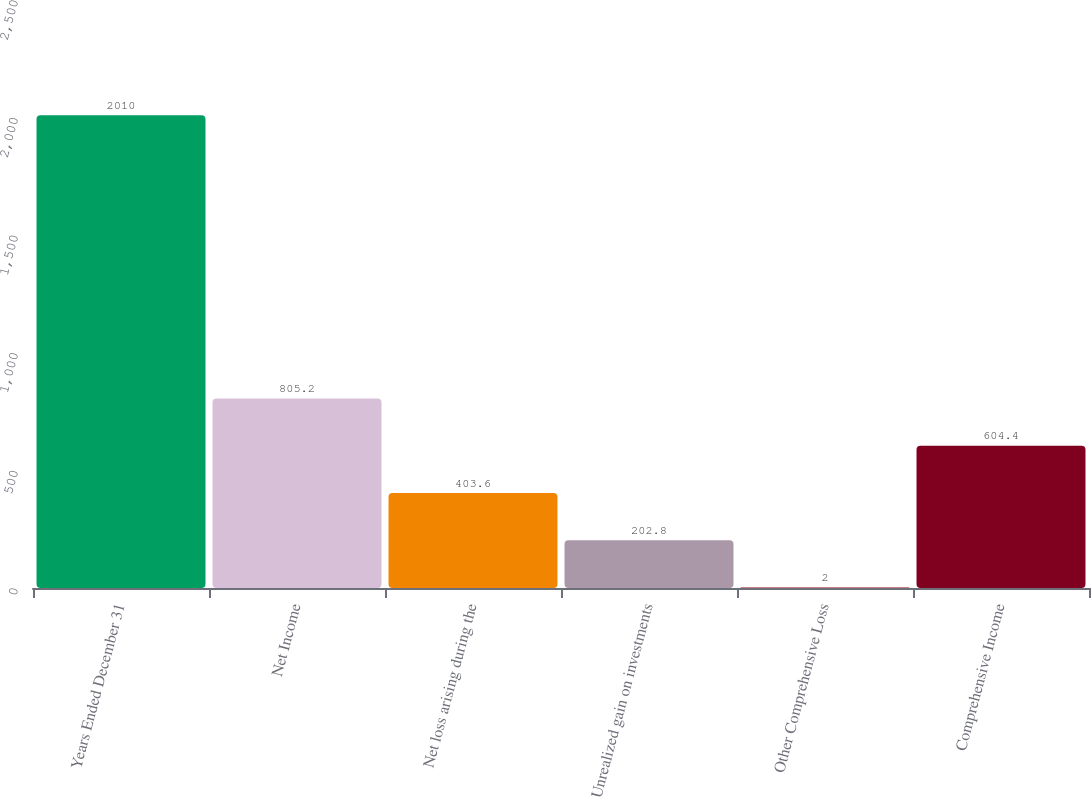Convert chart. <chart><loc_0><loc_0><loc_500><loc_500><bar_chart><fcel>Years Ended December 31<fcel>Net Income<fcel>Net loss arising during the<fcel>Unrealized gain on investments<fcel>Other Comprehensive Loss<fcel>Comprehensive Income<nl><fcel>2010<fcel>805.2<fcel>403.6<fcel>202.8<fcel>2<fcel>604.4<nl></chart> 